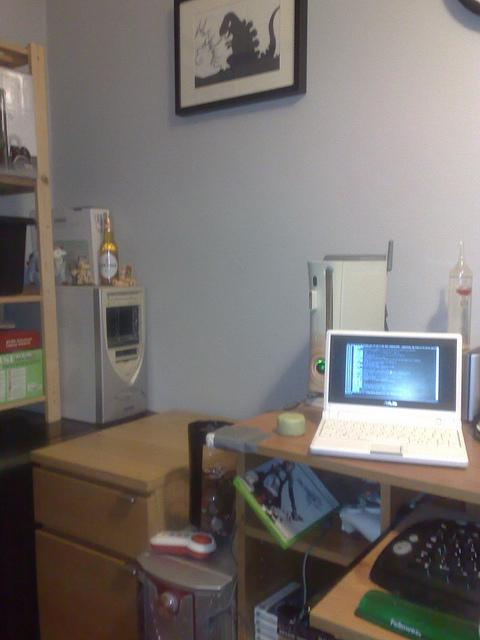What kind of beverage is sat atop of the computer tower in the corner of this room? beer 